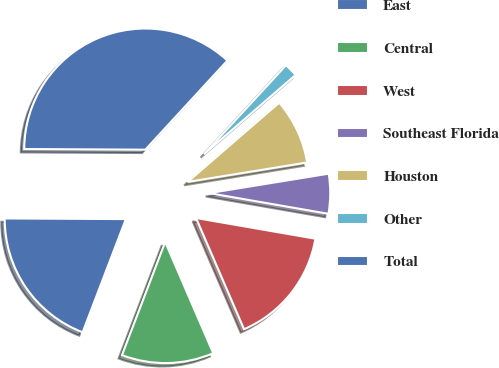Convert chart to OTSL. <chart><loc_0><loc_0><loc_500><loc_500><pie_chart><fcel>East<fcel>Central<fcel>West<fcel>Southeast Florida<fcel>Houston<fcel>Other<fcel>Total<nl><fcel>19.28%<fcel>12.29%<fcel>15.78%<fcel>5.3%<fcel>8.79%<fcel>1.8%<fcel>36.76%<nl></chart> 